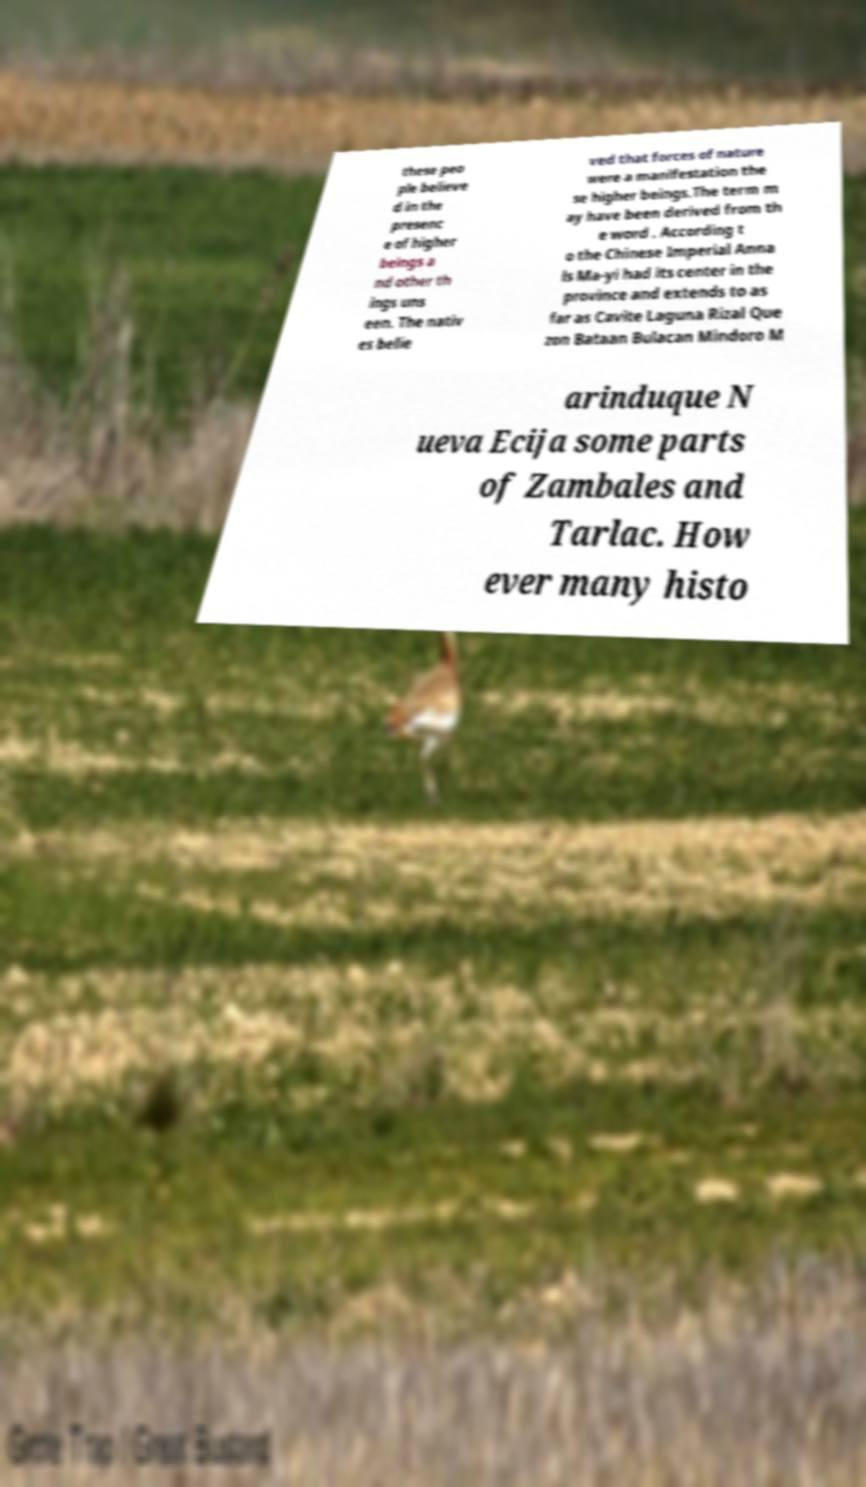Could you extract and type out the text from this image? these peo ple believe d in the presenc e of higher beings a nd other th ings uns een. The nativ es belie ved that forces of nature were a manifestation the se higher beings.The term m ay have been derived from th e word . According t o the Chinese Imperial Anna ls Ma-yi had its center in the province and extends to as far as Cavite Laguna Rizal Que zon Bataan Bulacan Mindoro M arinduque N ueva Ecija some parts of Zambales and Tarlac. How ever many histo 